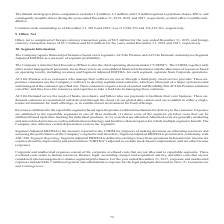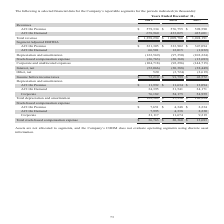According to Aci Worldwide's financial document, Which group of people does ACI on Premise serve? customers who manage their software on site or through a third-party cloud service provider.. The document states: "e from Corporate operations. ACI On Premise serves customers who manage their software on site or through a third-party cloud service provider. These ..." Also, Which group of people does ACI on Demand serve? the needs of banks, merchants, and billers who use payments to facilitate their core business. The document states: "in managing these solutions. ACI On Demand serves the needs of banks, merchants, and billers who use payments to facilitate their core business. These..." Also, What was the ACI on Premise revenue in 2019? According to the financial document, $579,334 (in thousands). The relevant text states: "ACI On Premise $ 579,334 $ 576,755 $ 598,590..." Also, can you calculate: What was the change in ACI on demand revenue between 2018 and 2019? Based on the calculation: 678,960-433,025, the result is 245935 (in thousands). This is based on the information: "ACI On Demand 678,960 433,025 425,601 ACI On Demand 678,960 433,025 425,601..." The key data points involved are: 433,025, 678,960. Also, can you calculate: What was the change in total revenue between 2018 and 2017? Based on the calculation: $1,009,780-$1,024,191, the result is -14411 (in thousands). This is based on the information: "Total revenue $ 1,258,294 $ 1,009,780 $ 1,024,191 Total revenue $ 1,258,294 $ 1,009,780 $ 1,024,191..." The key data points involved are: 1,009,780, 1,024,191. Also, can you calculate: What was the percentage change in Total stock-based compensation expense between 2018 and 2019? To answer this question, I need to perform calculations using the financial data. The calculation is: ($36,763-$20,360)/$20,360, which equals 80.56 (percentage). This is based on the information: "Stock-based compensation expense (36,763 ) (20,360 ) (13,683 ) Stock-based compensation expense (36,763 ) (20,360 ) (13,683 )..." The key data points involved are: 20,360, 36,763. 